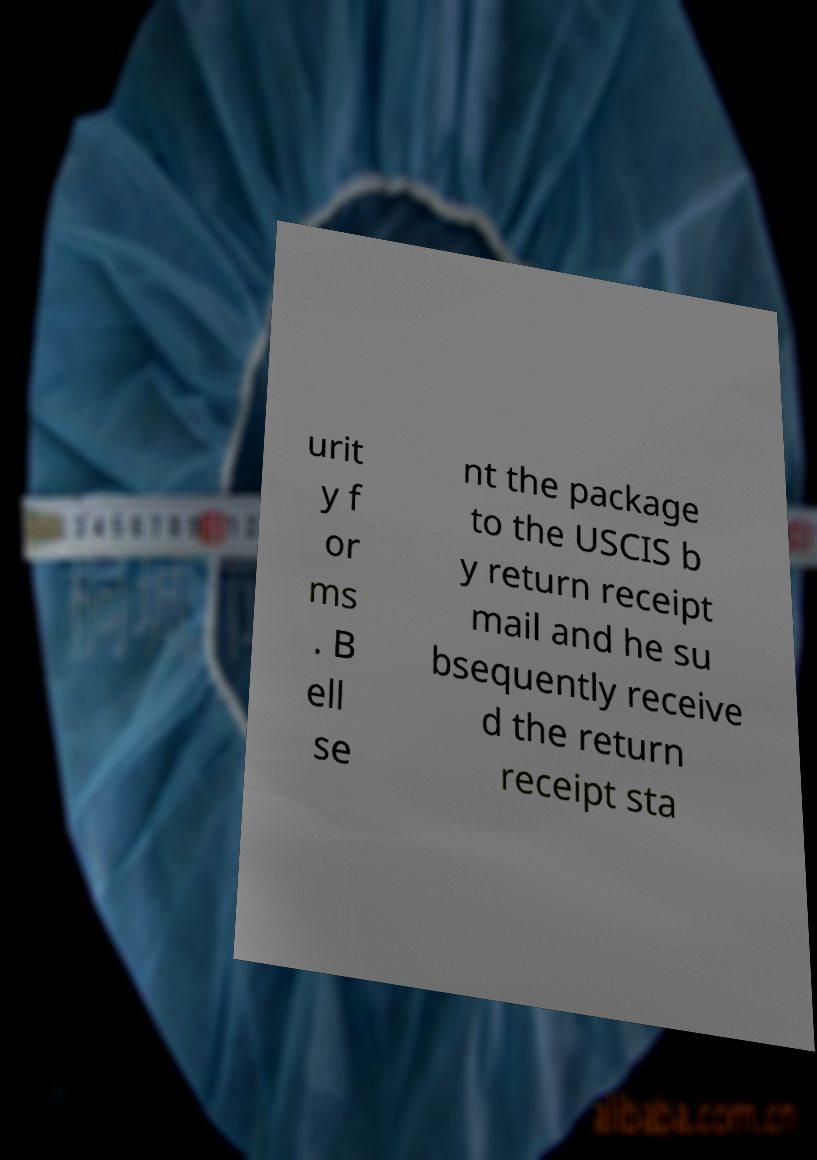Could you extract and type out the text from this image? urit y f or ms . B ell se nt the package to the USCIS b y return receipt mail and he su bsequently receive d the return receipt sta 